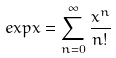Convert formula to latex. <formula><loc_0><loc_0><loc_500><loc_500>e x p x = \sum _ { n = 0 } ^ { \infty } \frac { x ^ { n } } { n ! }</formula> 